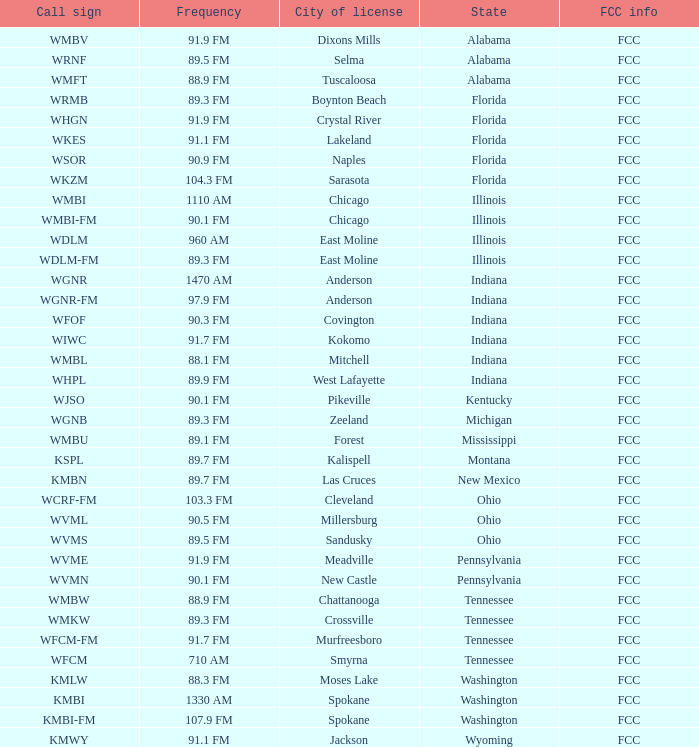What is the call sign for 90.9 FM which is in Florida? WSOR. 